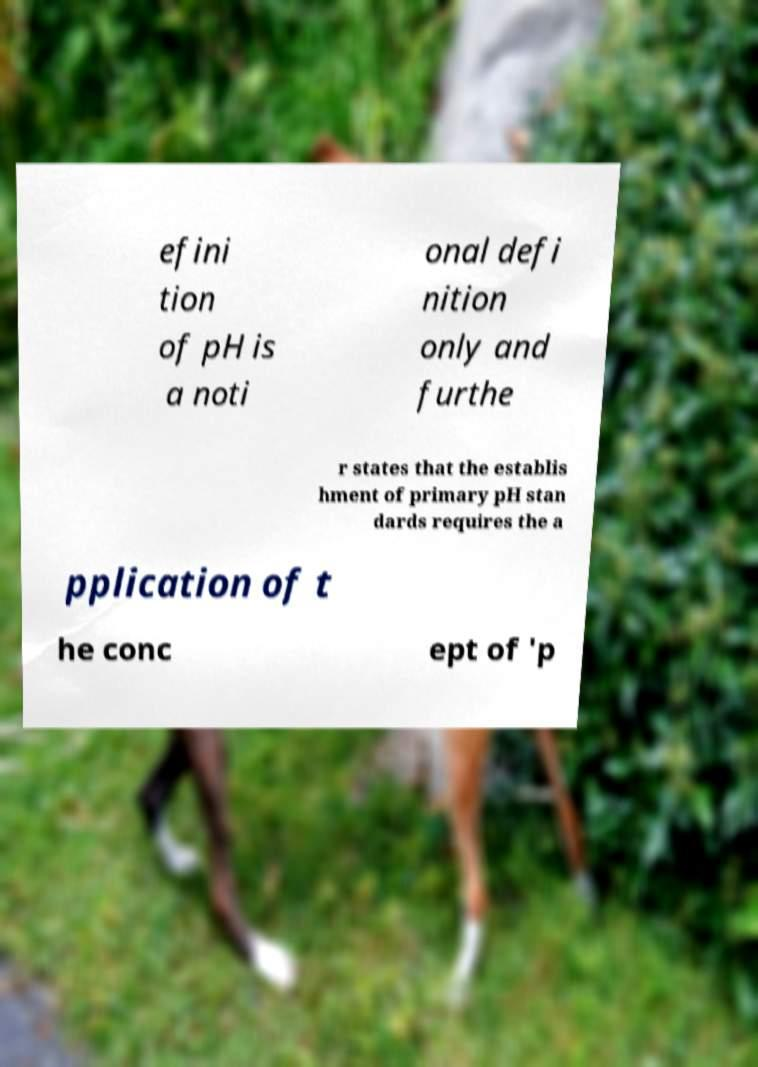What messages or text are displayed in this image? I need them in a readable, typed format. efini tion of pH is a noti onal defi nition only and furthe r states that the establis hment of primary pH stan dards requires the a pplication of t he conc ept of 'p 